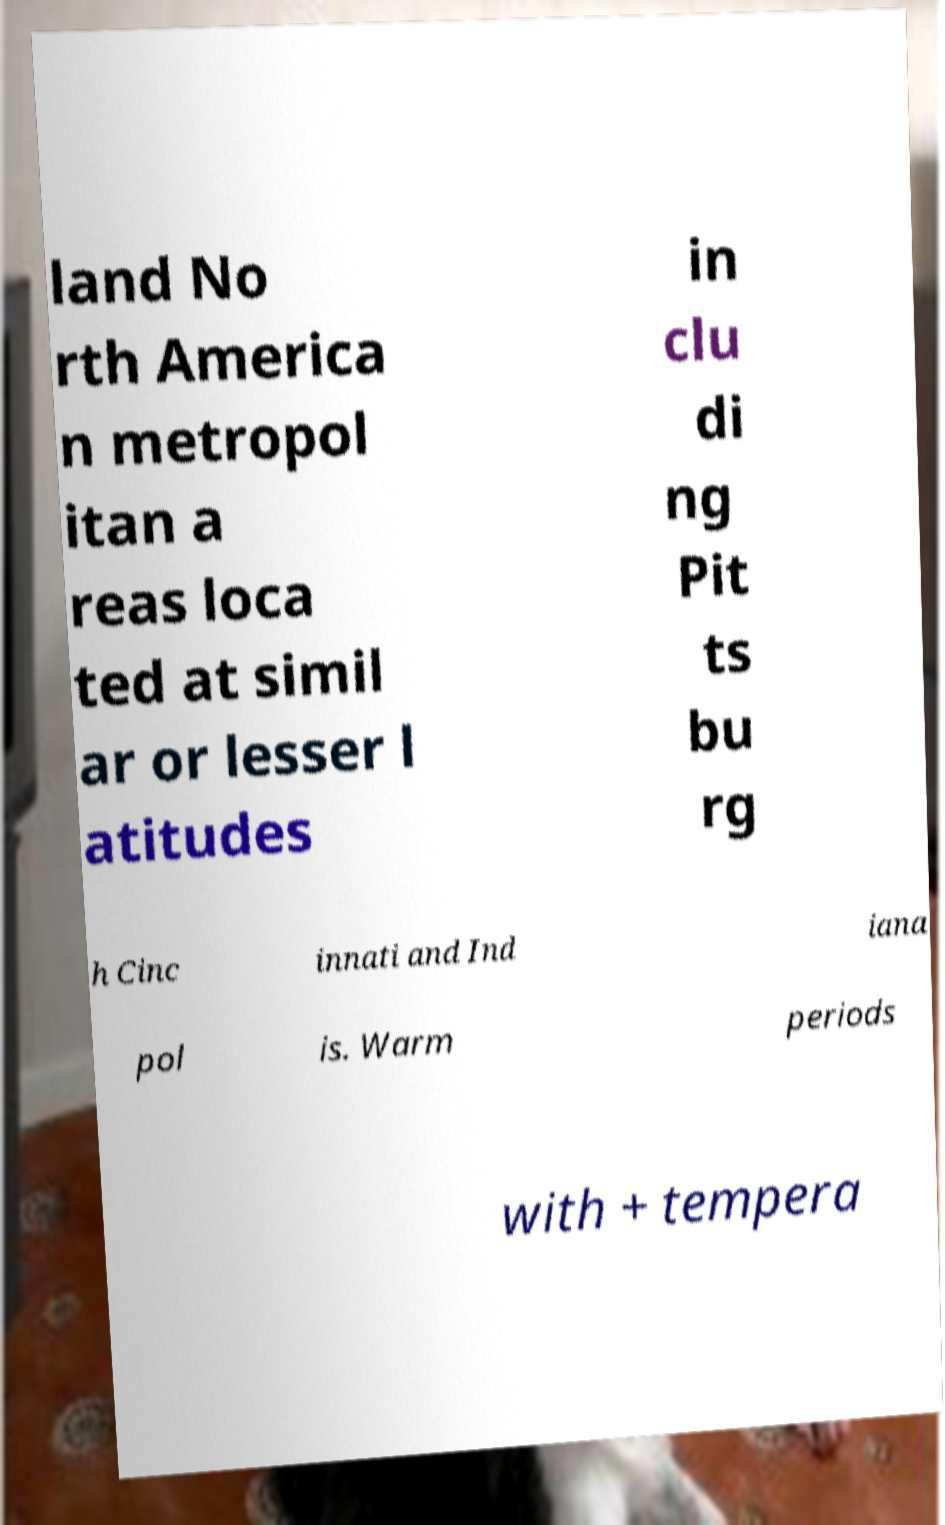Please read and relay the text visible in this image. What does it say? land No rth America n metropol itan a reas loca ted at simil ar or lesser l atitudes in clu di ng Pit ts bu rg h Cinc innati and Ind iana pol is. Warm periods with + tempera 